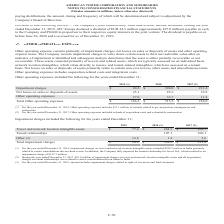According to American Tower Corporation's financial document, For the year ended December 31, 2019, what did the amount in Other include? impairment charges related to right-of-use assets and land easements.. The document states: "the year ended December 31, 2019, amount includes impairment charges related to right-of-use assets and land easements...." Also, How much were the total impairment charges in 2017? According to the financial document, $211.4 (in millions). The relevant text states: "Impairment charges $ 94.2 $ 394.0 $ 211.4..." Also, What were the Tower and network location intangible assets in 2019? According to the financial document, $77.4 (in millions). The relevant text states: "Tower and network location intangible assets $ 77.4 $ 284.9 $ 108.7..." Also, How many years were the total impairment charges above $200 million? Counting the relevant items in the document: 2018, 2017, I find 2 instances. The key data points involved are: 2017, 2018. Also, How many years were the Tower and network location intangible assets above $100 million? Counting the relevant items in the document: 2018, 2017, I find 2 instances. The key data points involved are: 2017, 2018. Also, can you calculate: What was the percentage change in Total impairment charges between 2018 and 2019? To answer this question, I need to perform calculations using the financial data. The calculation is: ($94.2-$394.0)/$394.0, which equals -76.09 (percentage). This is based on the information: "Impairment charges $ 94.2 $ 394.0 $ 211.4 Impairment charges $ 94.2 $ 394.0 $ 211.4..." The key data points involved are: 394.0, 94.2. 